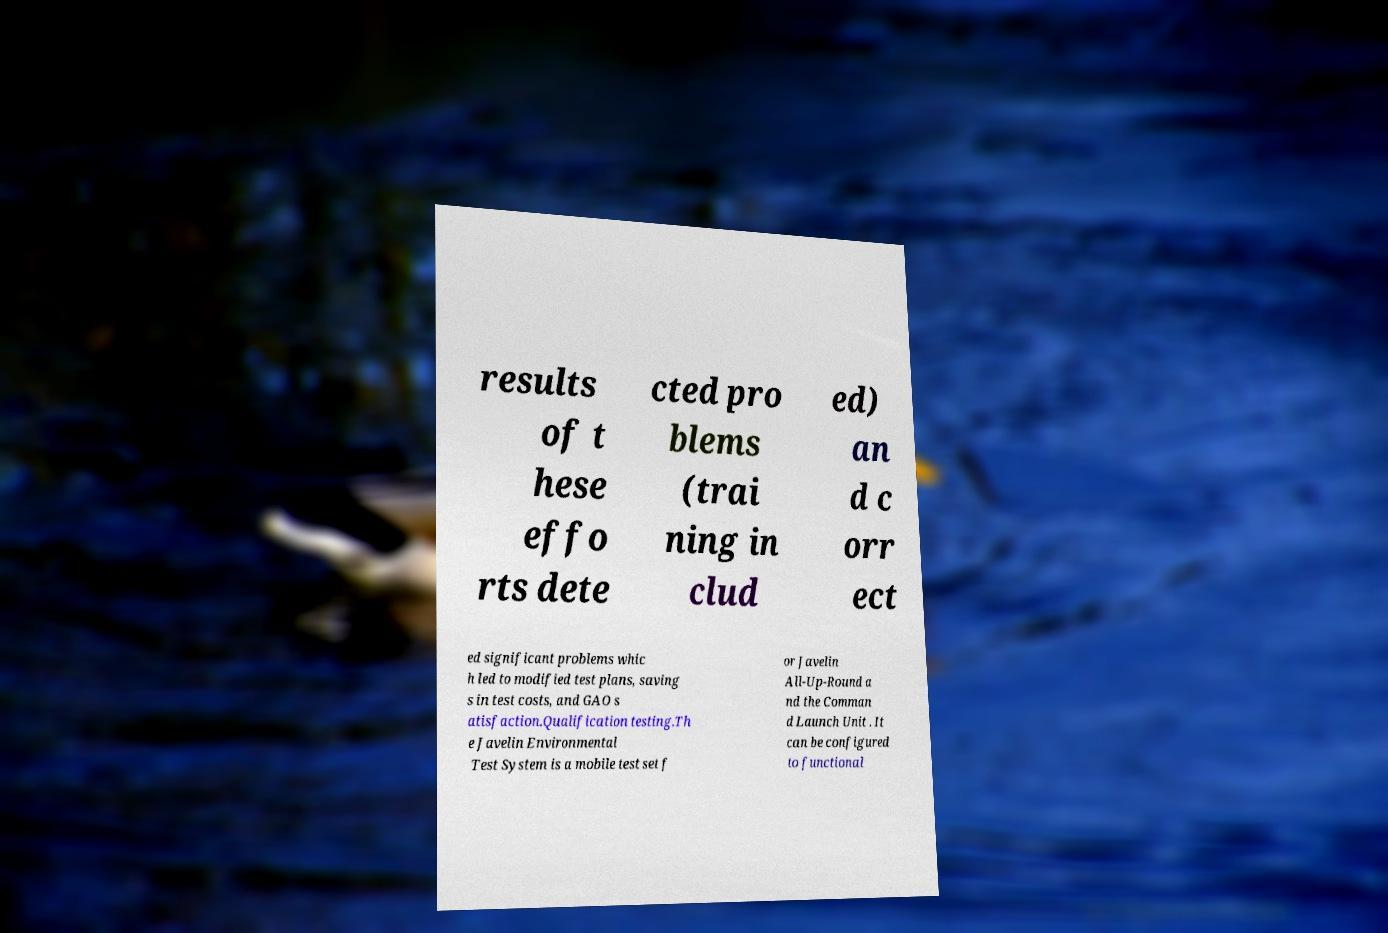There's text embedded in this image that I need extracted. Can you transcribe it verbatim? results of t hese effo rts dete cted pro blems (trai ning in clud ed) an d c orr ect ed significant problems whic h led to modified test plans, saving s in test costs, and GAO s atisfaction.Qualification testing.Th e Javelin Environmental Test System is a mobile test set f or Javelin All-Up-Round a nd the Comman d Launch Unit . It can be configured to functional 